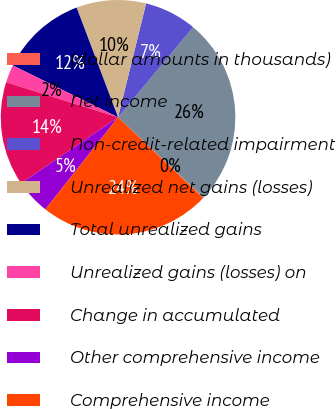Convert chart to OTSL. <chart><loc_0><loc_0><loc_500><loc_500><pie_chart><fcel>(dollar amounts in thousands)<fcel>Net income<fcel>Non-credit-related impairment<fcel>Unrealized net gains (losses)<fcel>Total unrealized gains<fcel>Unrealized gains (losses) on<fcel>Change in accumulated<fcel>Other comprehensive income<fcel>Comprehensive income<nl><fcel>0.08%<fcel>25.94%<fcel>7.21%<fcel>9.59%<fcel>11.97%<fcel>2.46%<fcel>14.35%<fcel>4.84%<fcel>23.56%<nl></chart> 